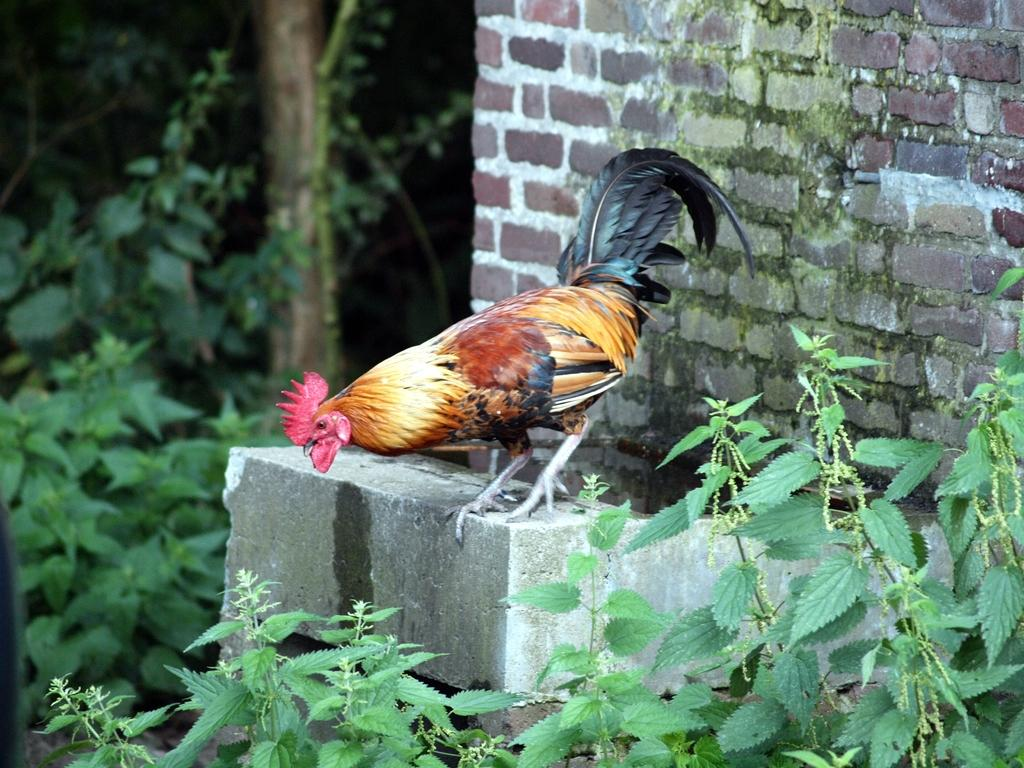What animal can be seen in the image? There is a hen in the image. Where is the hen located in relation to the brick wall? The hen is standing near a brick wall. What type of vegetation is visible at the bottom of the image? There are many leaves visible at the bottom of the image. What can be seen on the left side of the image? There are plants and a tree on the left side of the image. What type of grape is being hammered into space in the image? There is no grape or hammer present in the image, nor is there any indication of space. 